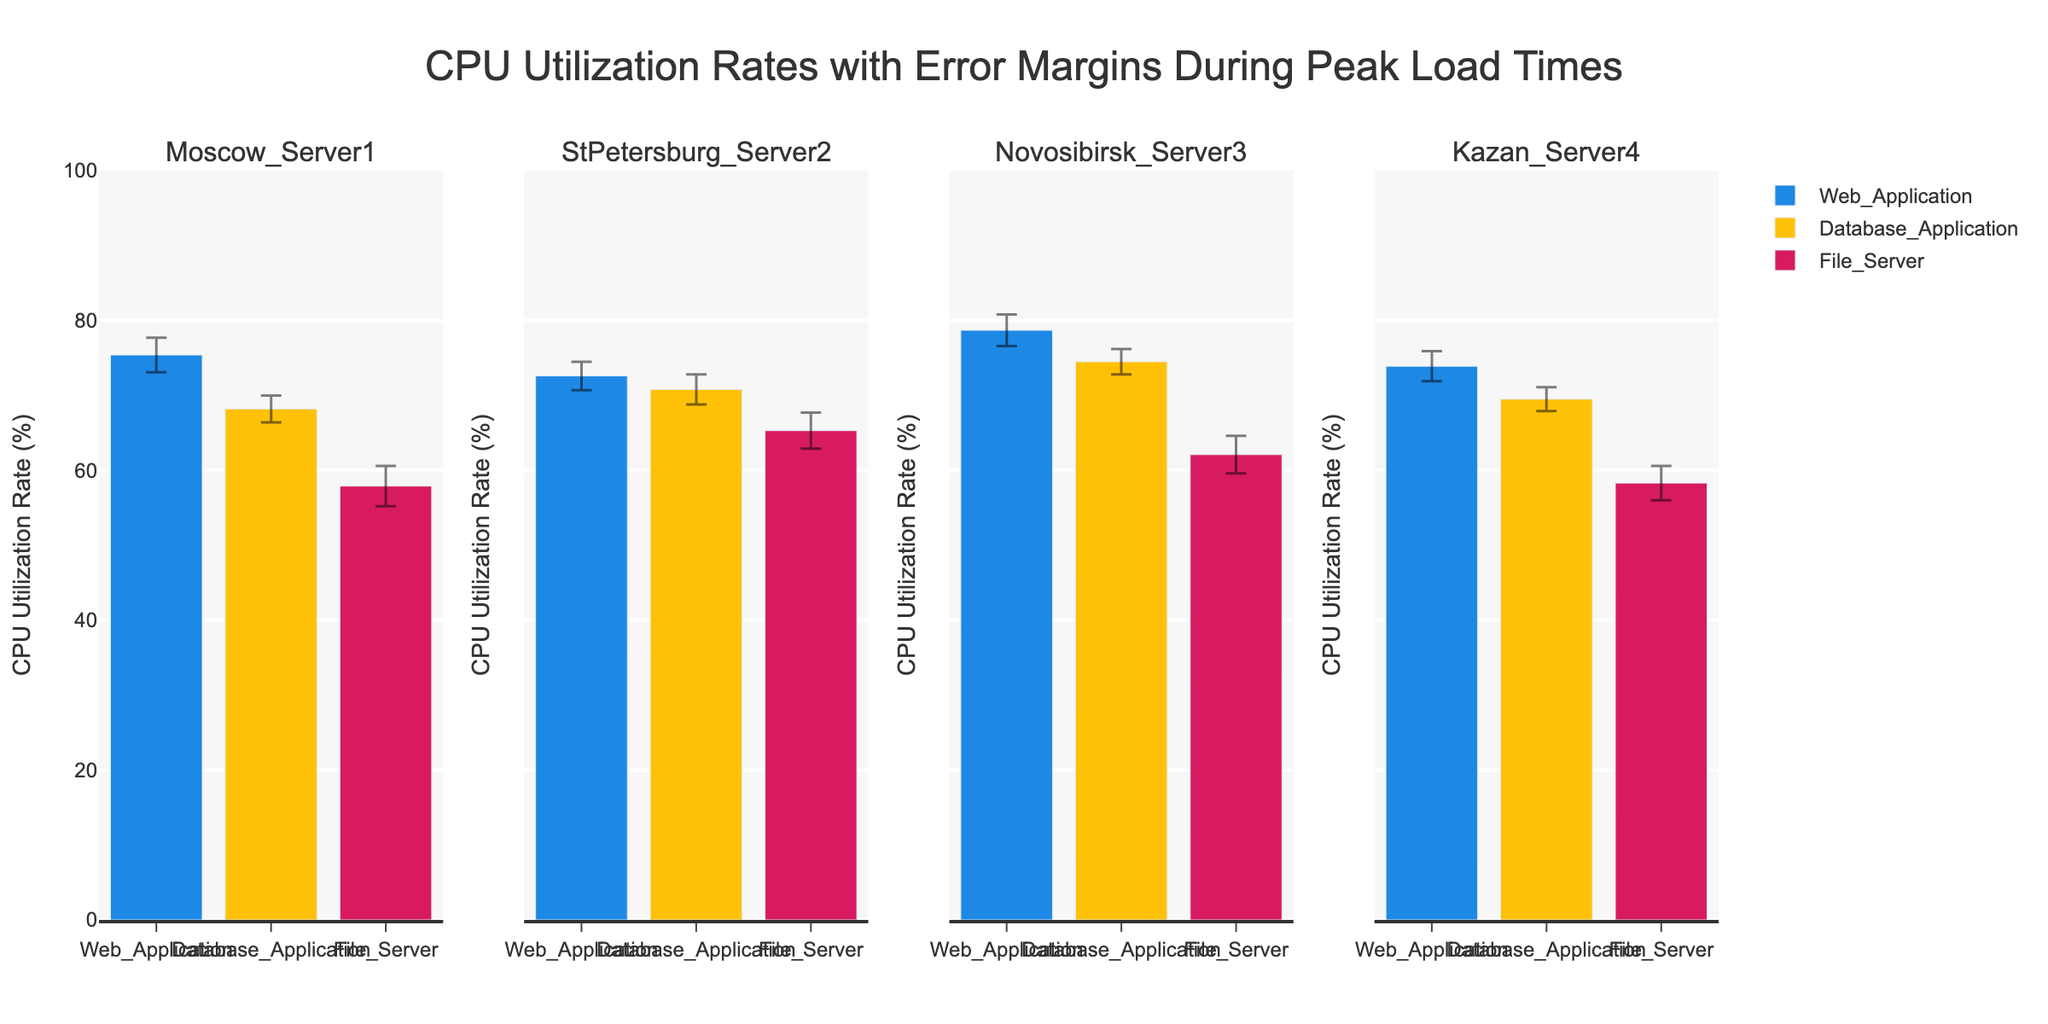Which server has the highest CPU utilization rate for the web application? Look for the highest bar in the "Web_Application" category across all servers. Novosibirsk_Server3 has the highest bar at 78.7%.
Answer: Novosibirsk_Server3 What is the title of the chart? The title is located at the top of the chart.
Answer: CPU Utilization Rates with Error Margins During Peak Load Times Which server has the lowest CPU utilization rate for the file server? Compare the bars for "File_Server" across all server subplots. Moscow_Server1 has the lowest rate at 57.9%.
Answer: Moscow_Server1 What is the CPU utilization rate for the Database Application on StPetersburg_Server2? Find the bar for "Database_Application" under StPetersburg_Server2. The rate is 70.8%.
Answer: 70.8% Which two servers have the most similar CPU utilization rates for the web application? Compare the bars for "Web_Application" across all servers. Moscow_Server1 and StPetersburg_Server2 have similar rates of 75.4% and 72.6%, respectively, with a difference of 2.8%.
Answer: Moscow_Server1 and StPetersburg_Server2 What is the average CPU utilization rate for the database application across all servers? The rates are 68.2 (Moscow_Server1), 70.8 (StPetersburg_Server2), 74.5 (Novosibirsk_Server3), and 69.5 (Kazan_Server4). Sum these values: 68.2 + 70.8 + 74.5 + 69.5 = 283. Then divide by 4: 283 / 4 = 70.75.
Answer: 70.75 Which application has the highest overall CPU utilization rate across all servers? Compare the highest individual rates for "Web_Application" (78.7), "Database_Application" (74.5), and "File_Server" (65.3). "Web_Application" has the highest rate at 78.7%.
Answer: Web_Application What is the combined error margin for CPU utilization for the file server on all servers? Sum the error margins for "File_Server" across all servers: 2.7 (Moscow_Server1) + 2.4 (StPetersburg_Server2) + 2.5 (Novosibirsk_Server3) + 2.3 (Kazan_Server4) = 9.9.
Answer: 9.9 Which server has the smallest error margin for the database application? Compare the error margins for "Database_Application" across all servers: 1.8 (Moscow_Server1), 2.0 (StPetersburg_Server2), 1.7 (Novosibirsk_Server3), and 1.6 (Kazan_Server4). Kazan_Server4 has the smallest error margin at 1.6.
Answer: Kazan_Server4 